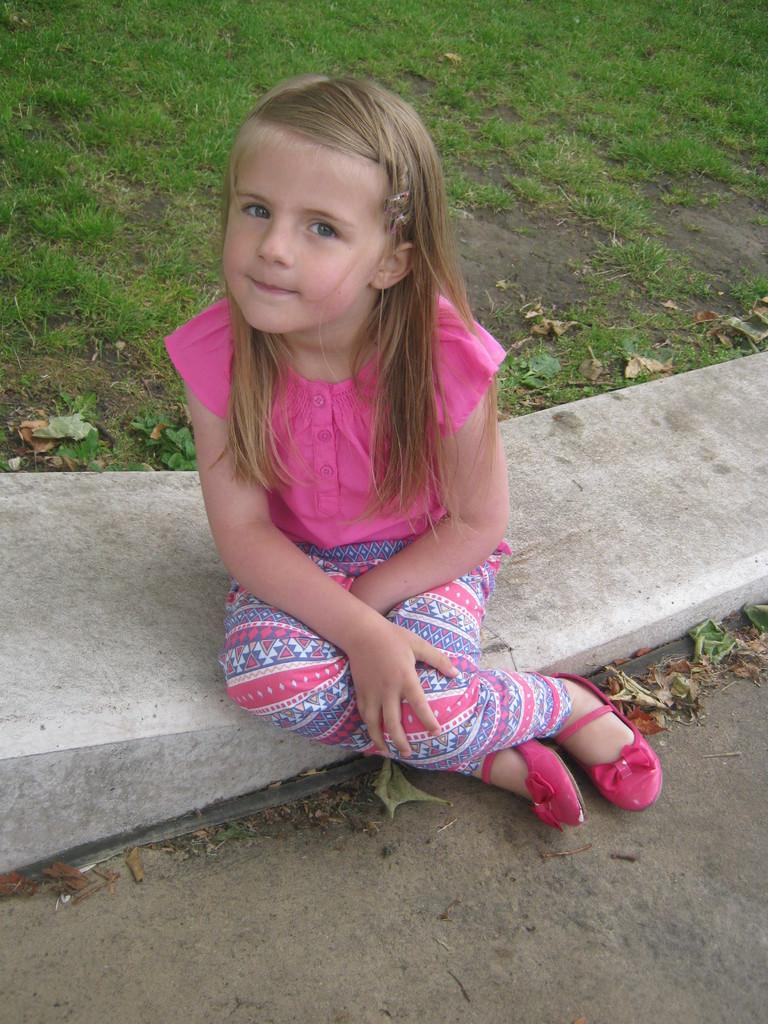What is the main subject of the image? There is a child sitting in the image. What can be seen in the background of the image? There are many grasses visible in the background of the image. What division is the child participating in within the image? There is no division or competition mentioned or visible in the image; it simply shows a child sitting. 